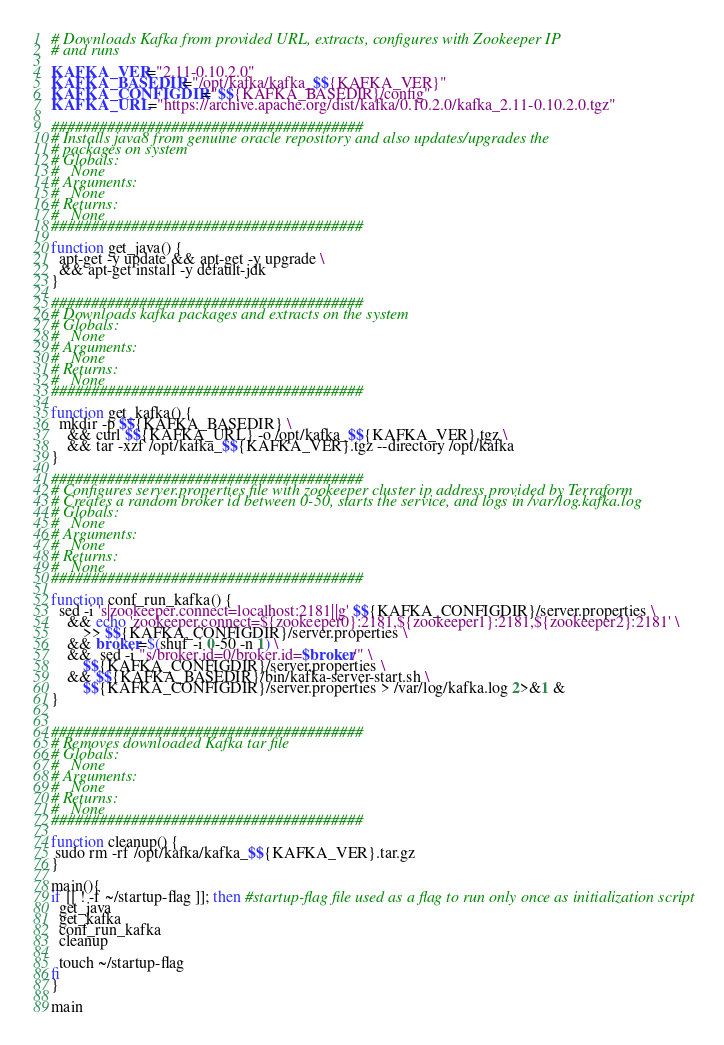Convert code to text. <code><loc_0><loc_0><loc_500><loc_500><_Bash_># Downloads Kafka from provided URL, extracts, configures with Zookeeper IP
# and runs

KAFKA_VER="2.11-0.10.2.0"
KAFKA_BASEDIR="/opt/kafka/kafka_$${KAFKA_VER}"
KAFKA_CONFIGDIR="$${KAFKA_BASEDIR}/config"
KAFKA_URL="https://archive.apache.org/dist/kafka/0.10.2.0/kafka_2.11-0.10.2.0.tgz"

#######################################
# Installs java8 from genuine oracle repository and also updates/upgrades the
# packages on system
# Globals:
#   None
# Arguments:
#   None
# Returns:
#   None
#######################################

function get_java() {
  apt-get -y update && apt-get -y upgrade \
  && apt-get install -y default-jdk
}

#######################################
# Downloads kafka packages and extracts on the system
# Globals:
#   None
# Arguments:
#   None
# Returns:
#   None
#######################################

function get_kafka() {
  mkdir -p $${KAFKA_BASEDIR} \
    && curl $${KAFKA_URL} -o /opt/kafka_$${KAFKA_VER}.tgz \
    && tar -xzf /opt/kafka_$${KAFKA_VER}.tgz --directory /opt/kafka
}

#######################################
# Configures server.properties file with zookeeper cluster ip address provided by Terraform
# Creates a random broker id between 0-50, starts the service, and logs in /var/log.kafka.log 
# Globals:
#   None
# Arguments:
#   None
# Returns:
#   None
#######################################

function conf_run_kafka() {
  sed -i 's|zookeeper.connect=localhost:2181||g' $${KAFKA_CONFIGDIR}/server.properties \
    && echo 'zookeeper.connect=${zookeeper0}:2181,${zookeeper1}:2181,${zookeeper2}:2181' \
        >> $${KAFKA_CONFIGDIR}/server.properties \
    && broker=$(shuf -i 0-50 -n 1) \
    &&  sed -i "s/broker.id=0/broker.id=$broker/" \
        $${KAFKA_CONFIGDIR}/server.properties \
    && $${KAFKA_BASEDIR}/bin/kafka-server-start.sh \
        $${KAFKA_CONFIGDIR}/server.properties > /var/log/kafka.log 2>&1 &
}


#######################################
# Removes downloaded Kafka tar file
# Globals:
#   None
# Arguments:
#   None
# Returns:
#   None
#######################################

function cleanup() {
 sudo rm -rf /opt/kafka/kafka_$${KAFKA_VER}.tar.gz
}

main(){
if [[ ! -f ~/startup-flag ]]; then #startup-flag file used as a flag to run only once as initialization script
  get_java
  get_kafka
  conf_run_kafka
  cleanup

  touch ~/startup-flag
fi
}

main
</code> 